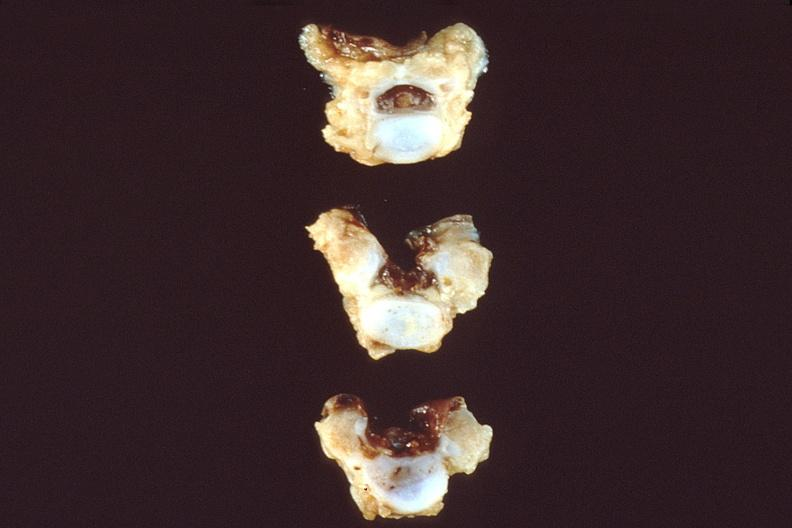what is present?
Answer the question using a single word or phrase. Nervous 